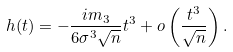<formula> <loc_0><loc_0><loc_500><loc_500>h ( t ) = - \frac { i m _ { 3 } } { 6 \sigma ^ { 3 } \sqrt { n } } t ^ { 3 } + o \left ( \frac { t ^ { 3 } } { \sqrt { n } } \right ) .</formula> 